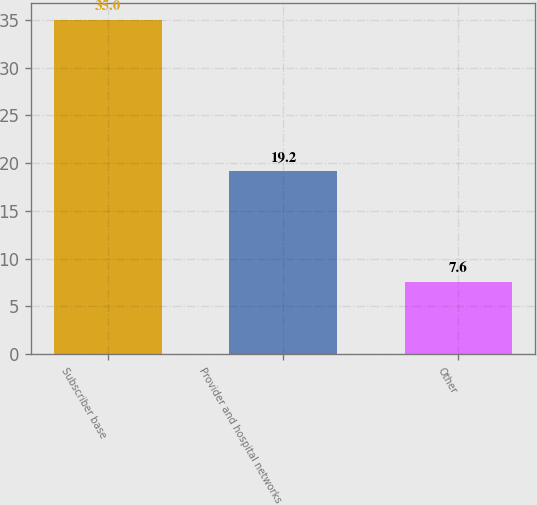Convert chart. <chart><loc_0><loc_0><loc_500><loc_500><bar_chart><fcel>Subscriber base<fcel>Provider and hospital networks<fcel>Other<nl><fcel>35<fcel>19.2<fcel>7.6<nl></chart> 